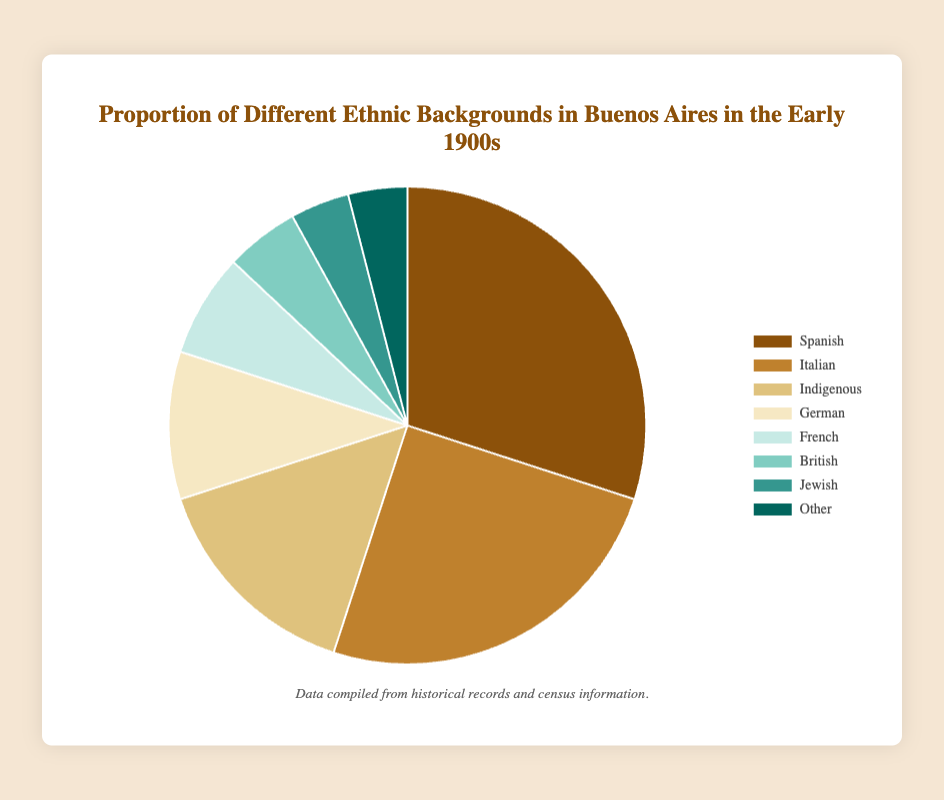Which ethnic group has the largest proportion in Buenos Aires in the early 1900s? By looking at the pie chart, we can see that the 'Spanish' section is the largest, showing the highest percentage.
Answer: Spanish What is the combined percentage of the Spanish and Italian populations? From the chart, the percentage for Spanish is 30% and for Italian is 25%. Adding these two values together: 30% + 25% = 55%.
Answer: 55% Which ethnic group has a larger proportion, German or French? By observing the pie chart, the German section is larger than the French one. The German population has 10%, while the French has 7%.
Answer: German What is the difference in percentage between the Indigenous and the British populations? From the chart, the Indigenous population is 15% and the British population is 5%. The difference is calculated as 15% - 5% = 10%.
Answer: 10% Which two ethnic groups have an equal proportion in Buenos Aires in the early 1900s? By examining the pie chart, we can see that both the Jewish and the Other sections each show a proportion of 4%.
Answer: Jewish and Other What is the total percentage of ethnic groups other than Spanish and Italian? First, sum the percentages of all ethnic groups: 30% + 25% + 15% + 10% + 7% + 5% + 4% + 4% = 100%. Then subtract the Spanish and Italian proportions: 100% - 30% - 25% = 45%.
Answer: 45% Which ethnic group is represented by the green section of the pie chart? By observing the colors in the pie chart, the green section corresponds to the Jewish population with a 4% share.
Answer: Jewish How much larger is the percentage of Indigenous groups compared to the Other ethnic groups? The pie chart shows that Indigenous has 15% and Other has 4%. The difference is calculated as 15% - 4% = 11%.
Answer: 11% Which ethnic group has a smaller proportion than the French but larger than the British? The pie chart indicates that the Jewish group has a smaller proportion than the French (7%) but larger than the British (5%). The Jewish population is at 4%.
Answer: Jewish What proportion of the population is made up by the German and British groups combined? The pie chart indicates that Germans make up 10% and the British make up 5%. Adding these two together gives 10% + 5% = 15%.
Answer: 15% 